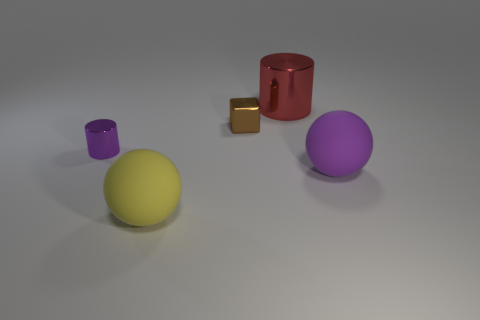Add 4 small blocks. How many objects exist? 9 Subtract all spheres. How many objects are left? 3 Add 5 small brown objects. How many small brown objects exist? 6 Subtract 0 green balls. How many objects are left? 5 Subtract all large matte balls. Subtract all brown shiny objects. How many objects are left? 2 Add 1 brown metal cubes. How many brown metal cubes are left? 2 